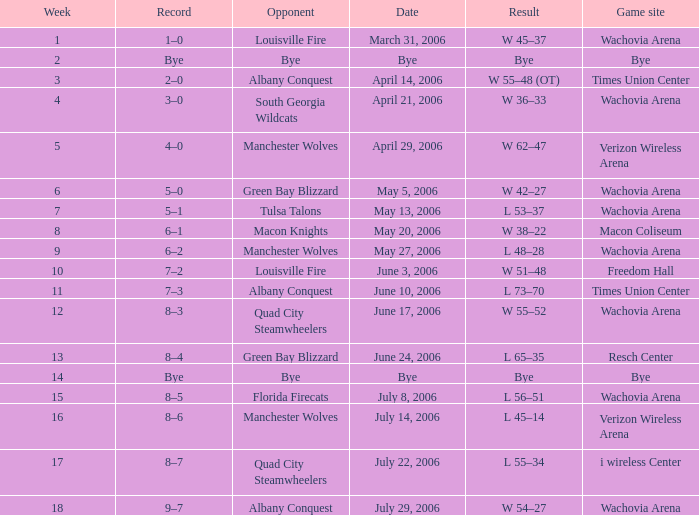What is the result for the game on May 27, 2006? L 48–28. 